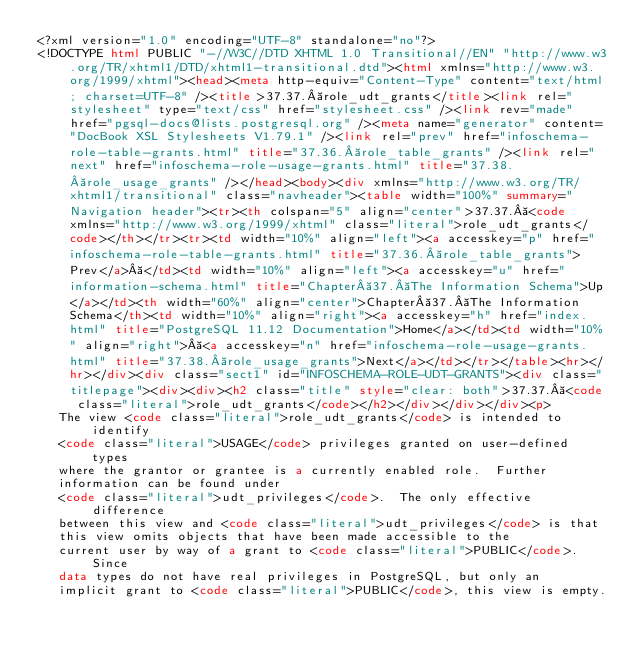<code> <loc_0><loc_0><loc_500><loc_500><_HTML_><?xml version="1.0" encoding="UTF-8" standalone="no"?>
<!DOCTYPE html PUBLIC "-//W3C//DTD XHTML 1.0 Transitional//EN" "http://www.w3.org/TR/xhtml1/DTD/xhtml1-transitional.dtd"><html xmlns="http://www.w3.org/1999/xhtml"><head><meta http-equiv="Content-Type" content="text/html; charset=UTF-8" /><title>37.37. role_udt_grants</title><link rel="stylesheet" type="text/css" href="stylesheet.css" /><link rev="made" href="pgsql-docs@lists.postgresql.org" /><meta name="generator" content="DocBook XSL Stylesheets V1.79.1" /><link rel="prev" href="infoschema-role-table-grants.html" title="37.36. role_table_grants" /><link rel="next" href="infoschema-role-usage-grants.html" title="37.38. role_usage_grants" /></head><body><div xmlns="http://www.w3.org/TR/xhtml1/transitional" class="navheader"><table width="100%" summary="Navigation header"><tr><th colspan="5" align="center">37.37. <code xmlns="http://www.w3.org/1999/xhtml" class="literal">role_udt_grants</code></th></tr><tr><td width="10%" align="left"><a accesskey="p" href="infoschema-role-table-grants.html" title="37.36. role_table_grants">Prev</a> </td><td width="10%" align="left"><a accesskey="u" href="information-schema.html" title="Chapter 37. The Information Schema">Up</a></td><th width="60%" align="center">Chapter 37. The Information Schema</th><td width="10%" align="right"><a accesskey="h" href="index.html" title="PostgreSQL 11.12 Documentation">Home</a></td><td width="10%" align="right"> <a accesskey="n" href="infoschema-role-usage-grants.html" title="37.38. role_usage_grants">Next</a></td></tr></table><hr></hr></div><div class="sect1" id="INFOSCHEMA-ROLE-UDT-GRANTS"><div class="titlepage"><div><div><h2 class="title" style="clear: both">37.37. <code class="literal">role_udt_grants</code></h2></div></div></div><p>
   The view <code class="literal">role_udt_grants</code> is intended to identify
   <code class="literal">USAGE</code> privileges granted on user-defined types
   where the grantor or grantee is a currently enabled role.  Further
   information can be found under
   <code class="literal">udt_privileges</code>.  The only effective difference
   between this view and <code class="literal">udt_privileges</code> is that
   this view omits objects that have been made accessible to the
   current user by way of a grant to <code class="literal">PUBLIC</code>.  Since
   data types do not have real privileges in PostgreSQL, but only an
   implicit grant to <code class="literal">PUBLIC</code>, this view is empty.</code> 